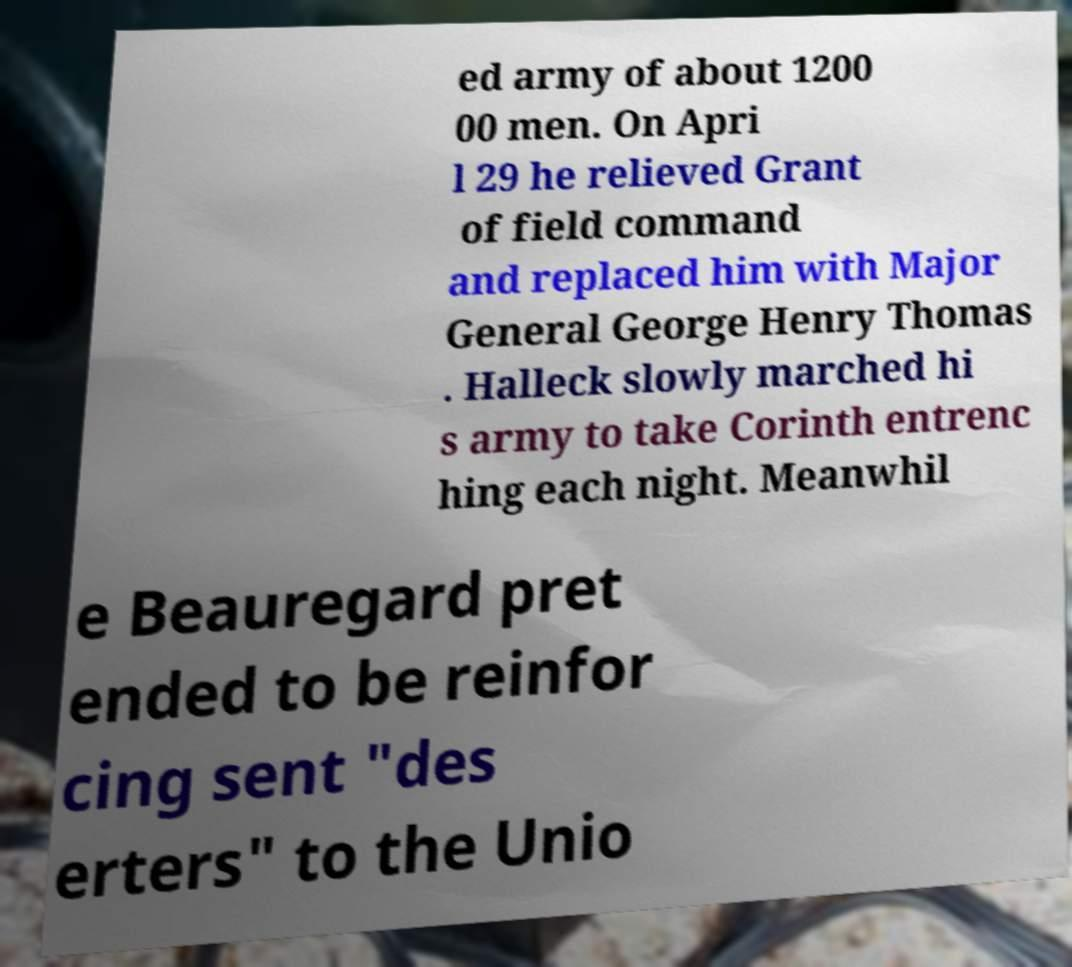I need the written content from this picture converted into text. Can you do that? ed army of about 1200 00 men. On Apri l 29 he relieved Grant of field command and replaced him with Major General George Henry Thomas . Halleck slowly marched hi s army to take Corinth entrenc hing each night. Meanwhil e Beauregard pret ended to be reinfor cing sent "des erters" to the Unio 